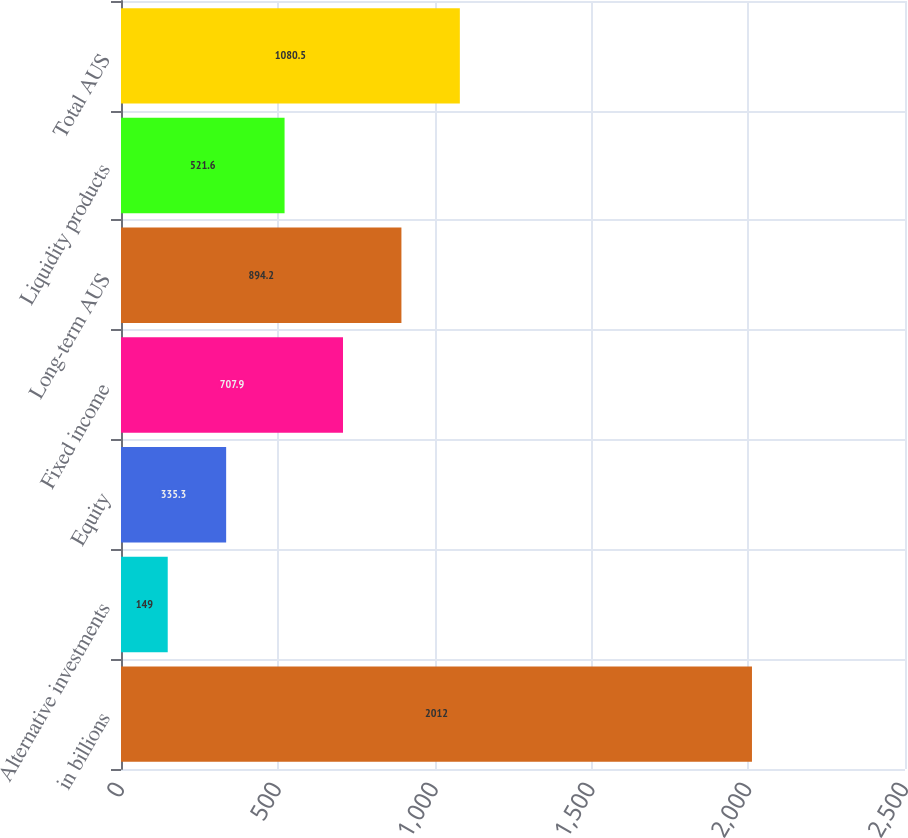Convert chart. <chart><loc_0><loc_0><loc_500><loc_500><bar_chart><fcel>in billions<fcel>Alternative investments<fcel>Equity<fcel>Fixed income<fcel>Long-term AUS<fcel>Liquidity products<fcel>Total AUS<nl><fcel>2012<fcel>149<fcel>335.3<fcel>707.9<fcel>894.2<fcel>521.6<fcel>1080.5<nl></chart> 